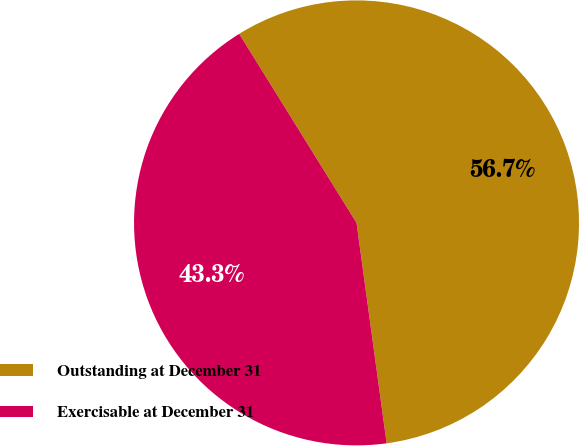Convert chart to OTSL. <chart><loc_0><loc_0><loc_500><loc_500><pie_chart><fcel>Outstanding at December 31<fcel>Exercisable at December 31<nl><fcel>56.68%<fcel>43.32%<nl></chart> 